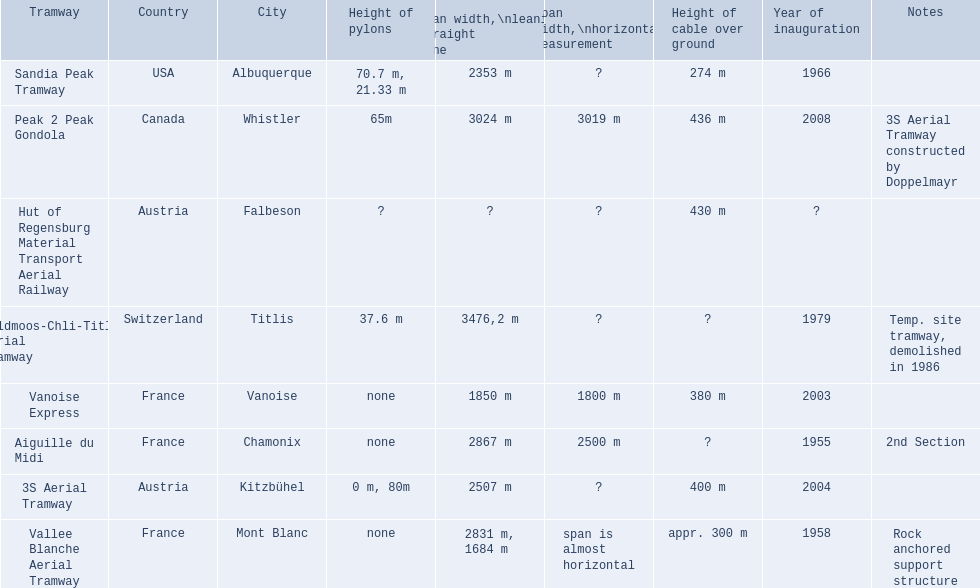Which tramways are in france? Vanoise Express, Aiguille du Midi, Vallee Blanche Aerial Tramway. Which of those were inaugurated in the 1950? Aiguille du Midi, Vallee Blanche Aerial Tramway. Which of these tramways span is not almost horizontal? Aiguille du Midi. 